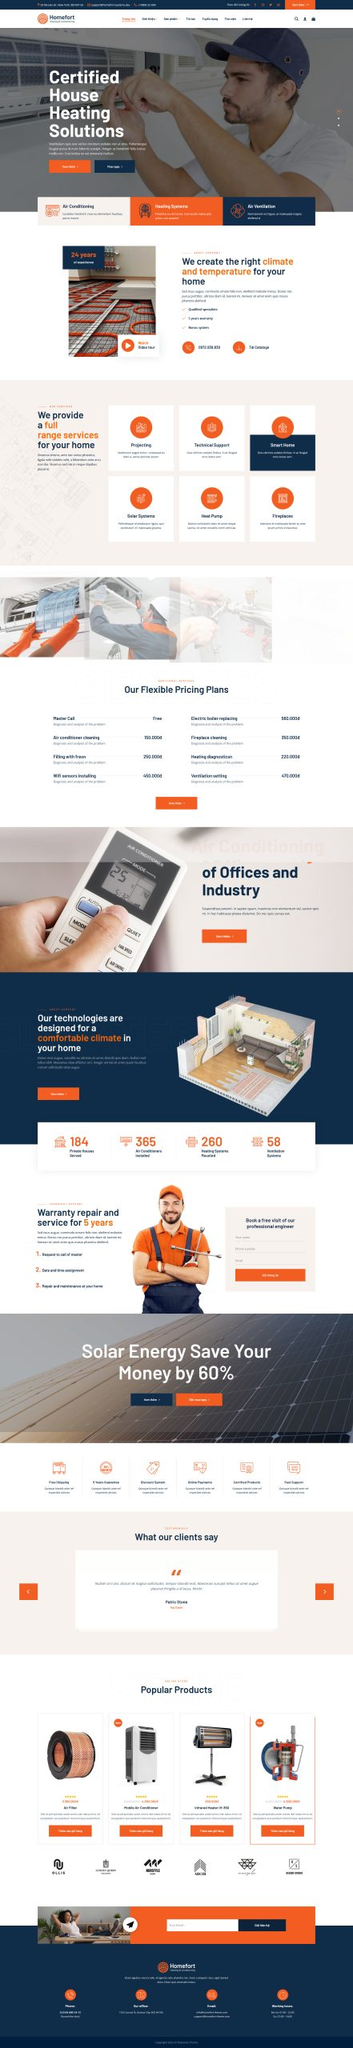Liệt kê 5 ngành nghề, lĩnh vực phù hợp với website này, phân cách các màu sắc bằng dấu phẩy. Chỉ trả về kết quả, phân cách bằng dấy phẩy
 Điều hòa không khí, Hệ thống sưởi, Thông gió, Năng lượng mặt trời, Sửa chữa thiết bị gia dụng 